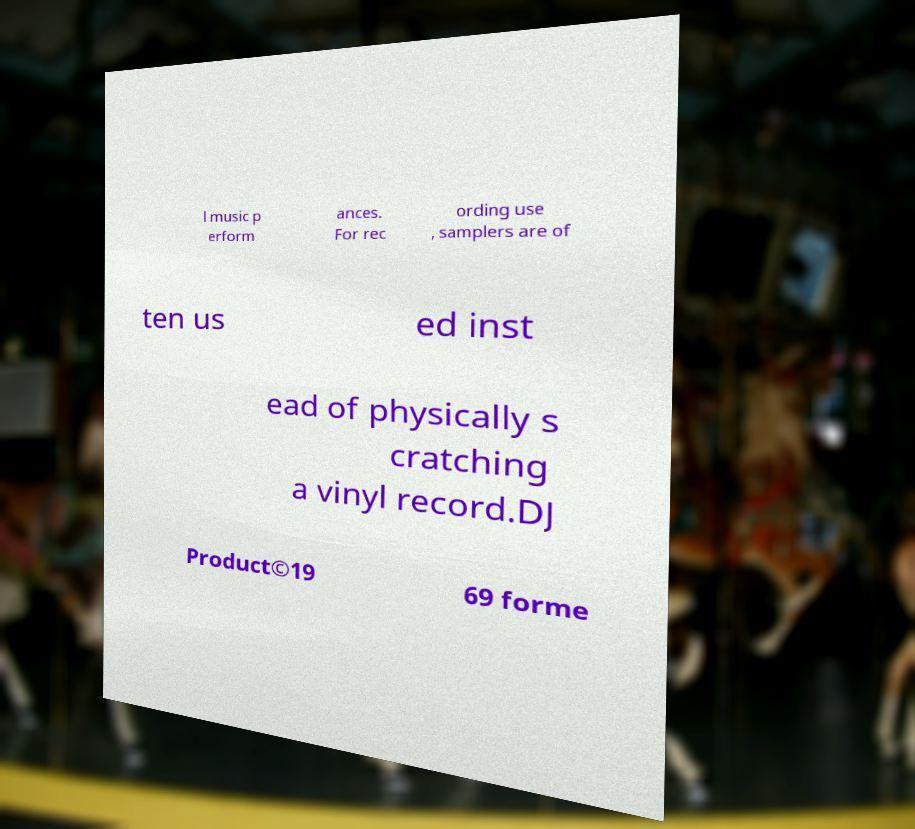Please read and relay the text visible in this image. What does it say? l music p erform ances. For rec ording use , samplers are of ten us ed inst ead of physically s cratching a vinyl record.DJ Product©19 69 forme 